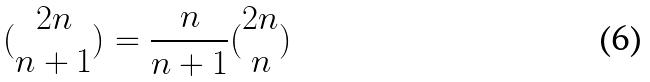Convert formula to latex. <formula><loc_0><loc_0><loc_500><loc_500>( \begin{matrix} 2 n \\ n + 1 \end{matrix} ) = \frac { n } { n + 1 } ( \begin{matrix} 2 n \\ n \end{matrix} )</formula> 